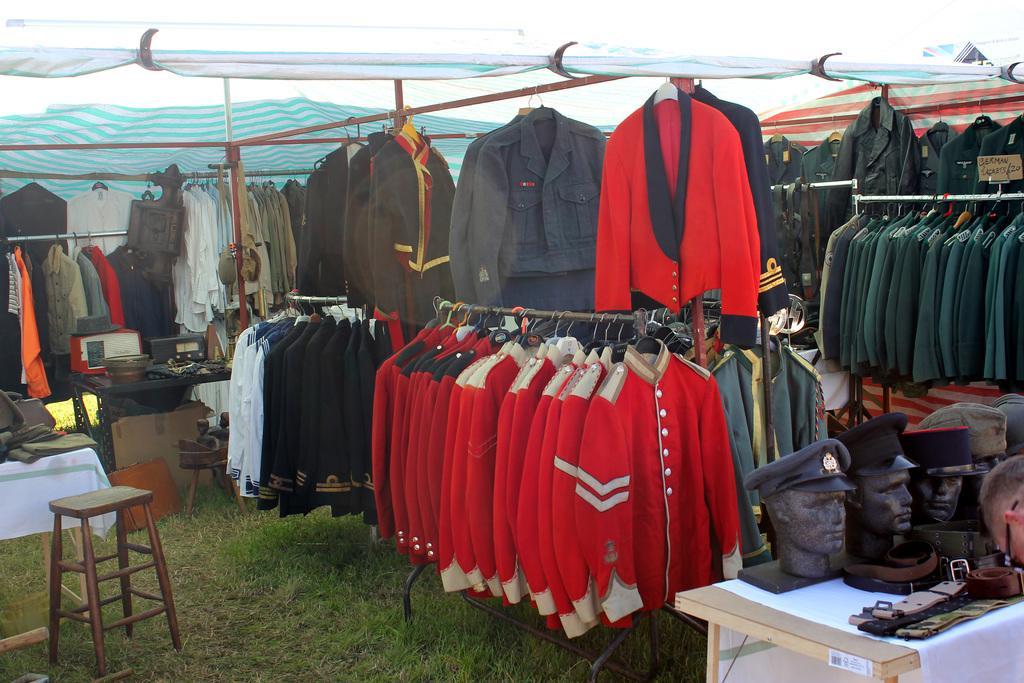Could you give a brief overview of what you see in this image? This picture contains many jackets which are in red, black, white, grey and blue in color. On the left bottom of the picture, we see stool. Beside it, we see a table on which jackets are placed. On the right bottom of the picture, we see a table on which statue of man with cap is placed on it. Above the picture, we see a green color tint. 